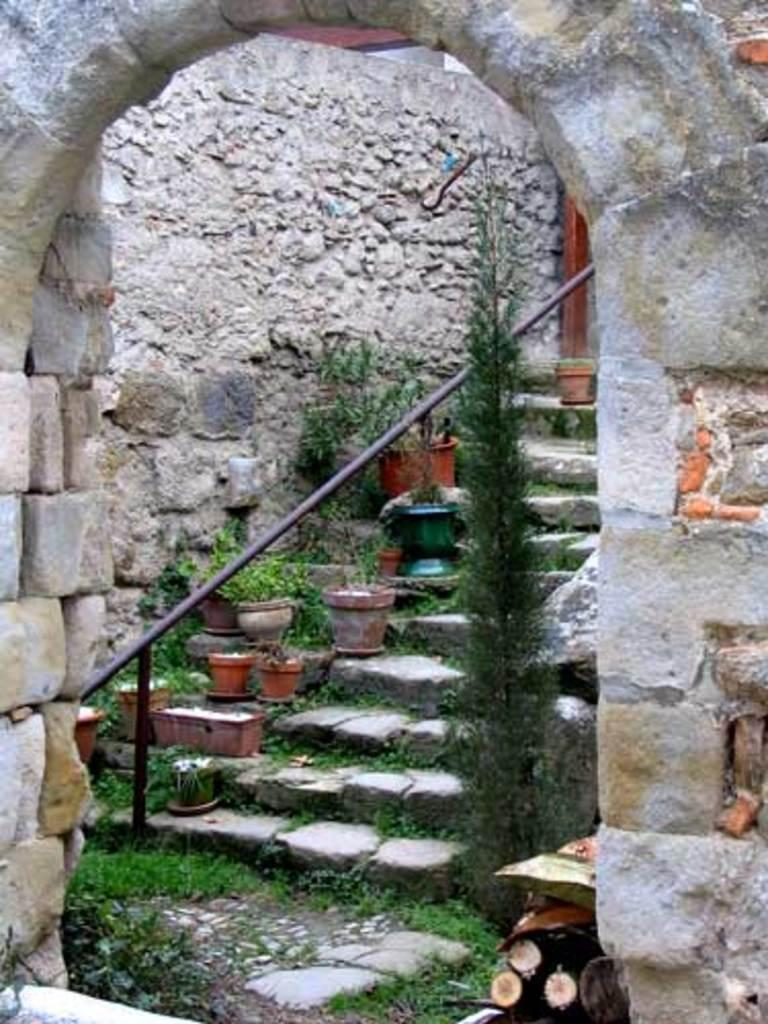What type of structure can be seen in the image? There is an arch in the image. What is located behind the arch? Plants are visible behind the arch. Are there any architectural features in the image? Yes, there are stairs in the image. What type of apparatus is being used to climb the stairs in the image? There is no apparatus visible in the image; the stairs can be climbed without any special equipment. 